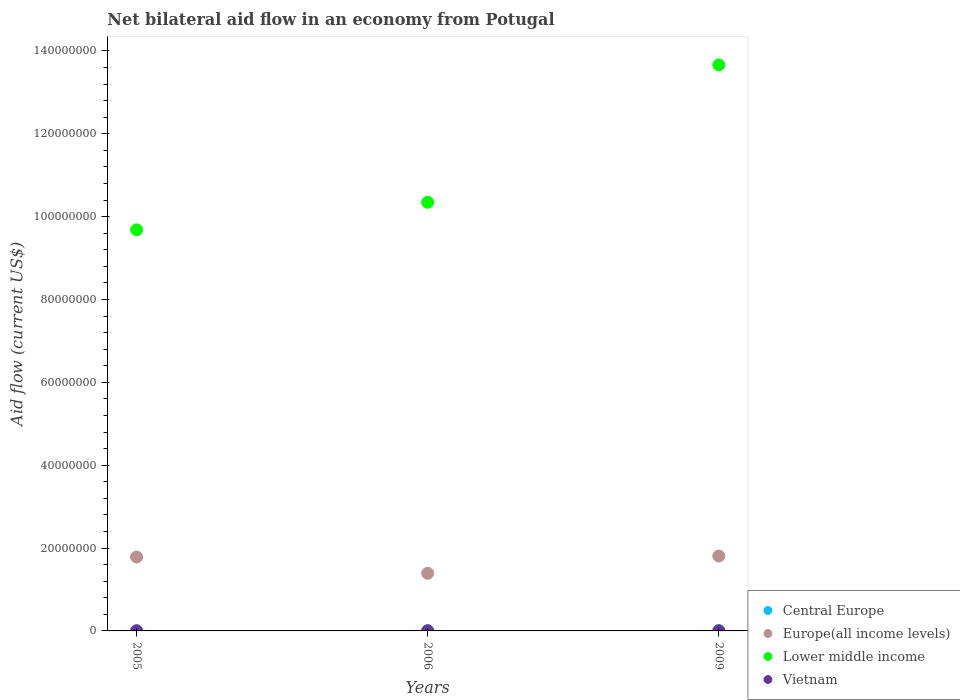How many different coloured dotlines are there?
Keep it short and to the point. 4. What is the net bilateral aid flow in Europe(all income levels) in 2005?
Give a very brief answer. 1.78e+07. Across all years, what is the maximum net bilateral aid flow in Lower middle income?
Provide a succinct answer. 1.37e+08. Across all years, what is the minimum net bilateral aid flow in Central Europe?
Your answer should be very brief. 5.00e+04. What is the total net bilateral aid flow in Central Europe in the graph?
Your response must be concise. 2.10e+05. What is the average net bilateral aid flow in Lower middle income per year?
Give a very brief answer. 1.12e+08. What is the ratio of the net bilateral aid flow in Europe(all income levels) in 2006 to that in 2009?
Give a very brief answer. 0.77. What is the difference between the highest and the second highest net bilateral aid flow in Vietnam?
Your answer should be compact. 0. Is the sum of the net bilateral aid flow in Lower middle income in 2005 and 2006 greater than the maximum net bilateral aid flow in Europe(all income levels) across all years?
Provide a succinct answer. Yes. Is it the case that in every year, the sum of the net bilateral aid flow in Europe(all income levels) and net bilateral aid flow in Central Europe  is greater than the sum of net bilateral aid flow in Vietnam and net bilateral aid flow in Lower middle income?
Make the answer very short. Yes. Is the net bilateral aid flow in Europe(all income levels) strictly less than the net bilateral aid flow in Lower middle income over the years?
Your answer should be compact. Yes. How many dotlines are there?
Your answer should be compact. 4. Does the graph contain any zero values?
Your answer should be very brief. No. Where does the legend appear in the graph?
Give a very brief answer. Bottom right. What is the title of the graph?
Ensure brevity in your answer.  Net bilateral aid flow in an economy from Potugal. Does "Panama" appear as one of the legend labels in the graph?
Your answer should be very brief. No. What is the label or title of the Y-axis?
Your answer should be compact. Aid flow (current US$). What is the Aid flow (current US$) of Central Europe in 2005?
Make the answer very short. 5.00e+04. What is the Aid flow (current US$) in Europe(all income levels) in 2005?
Your answer should be very brief. 1.78e+07. What is the Aid flow (current US$) in Lower middle income in 2005?
Provide a short and direct response. 9.68e+07. What is the Aid flow (current US$) in Europe(all income levels) in 2006?
Offer a terse response. 1.39e+07. What is the Aid flow (current US$) in Lower middle income in 2006?
Your answer should be very brief. 1.03e+08. What is the Aid flow (current US$) in Vietnam in 2006?
Offer a very short reply. 10000. What is the Aid flow (current US$) of Europe(all income levels) in 2009?
Keep it short and to the point. 1.81e+07. What is the Aid flow (current US$) of Lower middle income in 2009?
Offer a very short reply. 1.37e+08. Across all years, what is the maximum Aid flow (current US$) in Europe(all income levels)?
Offer a very short reply. 1.81e+07. Across all years, what is the maximum Aid flow (current US$) in Lower middle income?
Your answer should be compact. 1.37e+08. Across all years, what is the minimum Aid flow (current US$) in Europe(all income levels)?
Give a very brief answer. 1.39e+07. Across all years, what is the minimum Aid flow (current US$) of Lower middle income?
Ensure brevity in your answer.  9.68e+07. Across all years, what is the minimum Aid flow (current US$) of Vietnam?
Provide a short and direct response. 10000. What is the total Aid flow (current US$) in Europe(all income levels) in the graph?
Ensure brevity in your answer.  4.98e+07. What is the total Aid flow (current US$) in Lower middle income in the graph?
Your answer should be very brief. 3.37e+08. What is the difference between the Aid flow (current US$) in Central Europe in 2005 and that in 2006?
Offer a very short reply. -3.00e+04. What is the difference between the Aid flow (current US$) of Europe(all income levels) in 2005 and that in 2006?
Keep it short and to the point. 3.93e+06. What is the difference between the Aid flow (current US$) in Lower middle income in 2005 and that in 2006?
Provide a succinct answer. -6.64e+06. What is the difference between the Aid flow (current US$) in Vietnam in 2005 and that in 2006?
Provide a succinct answer. 0. What is the difference between the Aid flow (current US$) in Europe(all income levels) in 2005 and that in 2009?
Keep it short and to the point. -2.30e+05. What is the difference between the Aid flow (current US$) of Lower middle income in 2005 and that in 2009?
Make the answer very short. -3.98e+07. What is the difference between the Aid flow (current US$) of Europe(all income levels) in 2006 and that in 2009?
Provide a short and direct response. -4.16e+06. What is the difference between the Aid flow (current US$) of Lower middle income in 2006 and that in 2009?
Make the answer very short. -3.32e+07. What is the difference between the Aid flow (current US$) in Central Europe in 2005 and the Aid flow (current US$) in Europe(all income levels) in 2006?
Your answer should be compact. -1.39e+07. What is the difference between the Aid flow (current US$) of Central Europe in 2005 and the Aid flow (current US$) of Lower middle income in 2006?
Your answer should be compact. -1.03e+08. What is the difference between the Aid flow (current US$) in Central Europe in 2005 and the Aid flow (current US$) in Vietnam in 2006?
Provide a succinct answer. 4.00e+04. What is the difference between the Aid flow (current US$) of Europe(all income levels) in 2005 and the Aid flow (current US$) of Lower middle income in 2006?
Keep it short and to the point. -8.56e+07. What is the difference between the Aid flow (current US$) in Europe(all income levels) in 2005 and the Aid flow (current US$) in Vietnam in 2006?
Give a very brief answer. 1.78e+07. What is the difference between the Aid flow (current US$) in Lower middle income in 2005 and the Aid flow (current US$) in Vietnam in 2006?
Your answer should be very brief. 9.68e+07. What is the difference between the Aid flow (current US$) of Central Europe in 2005 and the Aid flow (current US$) of Europe(all income levels) in 2009?
Ensure brevity in your answer.  -1.80e+07. What is the difference between the Aid flow (current US$) of Central Europe in 2005 and the Aid flow (current US$) of Lower middle income in 2009?
Make the answer very short. -1.37e+08. What is the difference between the Aid flow (current US$) in Central Europe in 2005 and the Aid flow (current US$) in Vietnam in 2009?
Your answer should be compact. 4.00e+04. What is the difference between the Aid flow (current US$) in Europe(all income levels) in 2005 and the Aid flow (current US$) in Lower middle income in 2009?
Offer a terse response. -1.19e+08. What is the difference between the Aid flow (current US$) of Europe(all income levels) in 2005 and the Aid flow (current US$) of Vietnam in 2009?
Offer a very short reply. 1.78e+07. What is the difference between the Aid flow (current US$) of Lower middle income in 2005 and the Aid flow (current US$) of Vietnam in 2009?
Provide a succinct answer. 9.68e+07. What is the difference between the Aid flow (current US$) of Central Europe in 2006 and the Aid flow (current US$) of Europe(all income levels) in 2009?
Your answer should be very brief. -1.80e+07. What is the difference between the Aid flow (current US$) of Central Europe in 2006 and the Aid flow (current US$) of Lower middle income in 2009?
Give a very brief answer. -1.37e+08. What is the difference between the Aid flow (current US$) in Central Europe in 2006 and the Aid flow (current US$) in Vietnam in 2009?
Give a very brief answer. 7.00e+04. What is the difference between the Aid flow (current US$) in Europe(all income levels) in 2006 and the Aid flow (current US$) in Lower middle income in 2009?
Your answer should be compact. -1.23e+08. What is the difference between the Aid flow (current US$) of Europe(all income levels) in 2006 and the Aid flow (current US$) of Vietnam in 2009?
Give a very brief answer. 1.39e+07. What is the difference between the Aid flow (current US$) in Lower middle income in 2006 and the Aid flow (current US$) in Vietnam in 2009?
Give a very brief answer. 1.03e+08. What is the average Aid flow (current US$) of Central Europe per year?
Provide a short and direct response. 7.00e+04. What is the average Aid flow (current US$) in Europe(all income levels) per year?
Give a very brief answer. 1.66e+07. What is the average Aid flow (current US$) in Lower middle income per year?
Offer a terse response. 1.12e+08. In the year 2005, what is the difference between the Aid flow (current US$) of Central Europe and Aid flow (current US$) of Europe(all income levels)?
Your response must be concise. -1.78e+07. In the year 2005, what is the difference between the Aid flow (current US$) in Central Europe and Aid flow (current US$) in Lower middle income?
Your answer should be very brief. -9.68e+07. In the year 2005, what is the difference between the Aid flow (current US$) in Central Europe and Aid flow (current US$) in Vietnam?
Provide a short and direct response. 4.00e+04. In the year 2005, what is the difference between the Aid flow (current US$) of Europe(all income levels) and Aid flow (current US$) of Lower middle income?
Offer a terse response. -7.90e+07. In the year 2005, what is the difference between the Aid flow (current US$) of Europe(all income levels) and Aid flow (current US$) of Vietnam?
Provide a succinct answer. 1.78e+07. In the year 2005, what is the difference between the Aid flow (current US$) of Lower middle income and Aid flow (current US$) of Vietnam?
Provide a short and direct response. 9.68e+07. In the year 2006, what is the difference between the Aid flow (current US$) in Central Europe and Aid flow (current US$) in Europe(all income levels)?
Provide a succinct answer. -1.38e+07. In the year 2006, what is the difference between the Aid flow (current US$) in Central Europe and Aid flow (current US$) in Lower middle income?
Offer a very short reply. -1.03e+08. In the year 2006, what is the difference between the Aid flow (current US$) of Europe(all income levels) and Aid flow (current US$) of Lower middle income?
Your answer should be compact. -8.95e+07. In the year 2006, what is the difference between the Aid flow (current US$) of Europe(all income levels) and Aid flow (current US$) of Vietnam?
Your answer should be compact. 1.39e+07. In the year 2006, what is the difference between the Aid flow (current US$) in Lower middle income and Aid flow (current US$) in Vietnam?
Provide a short and direct response. 1.03e+08. In the year 2009, what is the difference between the Aid flow (current US$) of Central Europe and Aid flow (current US$) of Europe(all income levels)?
Offer a terse response. -1.80e+07. In the year 2009, what is the difference between the Aid flow (current US$) in Central Europe and Aid flow (current US$) in Lower middle income?
Your response must be concise. -1.37e+08. In the year 2009, what is the difference between the Aid flow (current US$) in Europe(all income levels) and Aid flow (current US$) in Lower middle income?
Give a very brief answer. -1.19e+08. In the year 2009, what is the difference between the Aid flow (current US$) in Europe(all income levels) and Aid flow (current US$) in Vietnam?
Offer a very short reply. 1.81e+07. In the year 2009, what is the difference between the Aid flow (current US$) in Lower middle income and Aid flow (current US$) in Vietnam?
Provide a short and direct response. 1.37e+08. What is the ratio of the Aid flow (current US$) in Europe(all income levels) in 2005 to that in 2006?
Offer a terse response. 1.28. What is the ratio of the Aid flow (current US$) of Lower middle income in 2005 to that in 2006?
Give a very brief answer. 0.94. What is the ratio of the Aid flow (current US$) of Europe(all income levels) in 2005 to that in 2009?
Give a very brief answer. 0.99. What is the ratio of the Aid flow (current US$) of Lower middle income in 2005 to that in 2009?
Offer a terse response. 0.71. What is the ratio of the Aid flow (current US$) in Central Europe in 2006 to that in 2009?
Offer a very short reply. 1. What is the ratio of the Aid flow (current US$) of Europe(all income levels) in 2006 to that in 2009?
Offer a terse response. 0.77. What is the ratio of the Aid flow (current US$) in Lower middle income in 2006 to that in 2009?
Ensure brevity in your answer.  0.76. What is the ratio of the Aid flow (current US$) of Vietnam in 2006 to that in 2009?
Give a very brief answer. 1. What is the difference between the highest and the second highest Aid flow (current US$) in Central Europe?
Keep it short and to the point. 0. What is the difference between the highest and the second highest Aid flow (current US$) in Lower middle income?
Your answer should be very brief. 3.32e+07. What is the difference between the highest and the lowest Aid flow (current US$) of Central Europe?
Provide a short and direct response. 3.00e+04. What is the difference between the highest and the lowest Aid flow (current US$) of Europe(all income levels)?
Provide a short and direct response. 4.16e+06. What is the difference between the highest and the lowest Aid flow (current US$) of Lower middle income?
Your answer should be very brief. 3.98e+07. What is the difference between the highest and the lowest Aid flow (current US$) of Vietnam?
Make the answer very short. 0. 